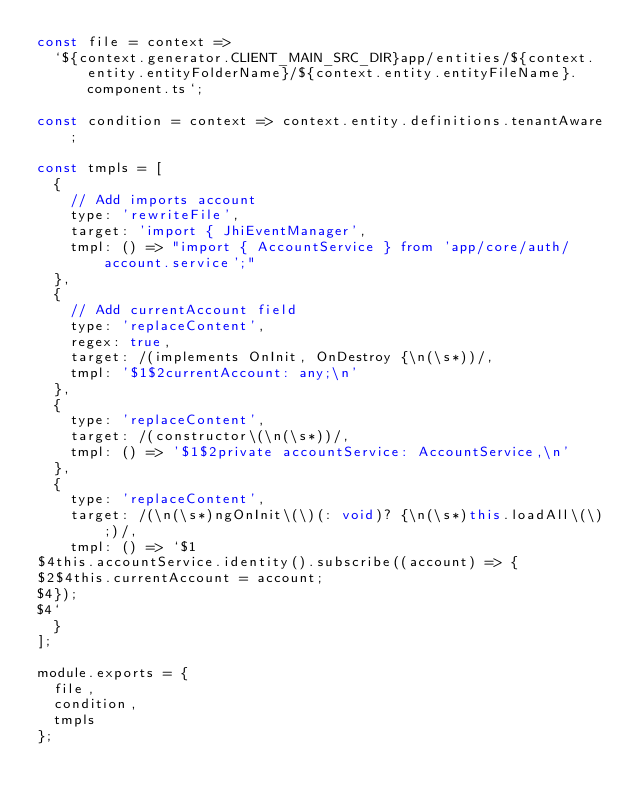<code> <loc_0><loc_0><loc_500><loc_500><_JavaScript_>const file = context =>
  `${context.generator.CLIENT_MAIN_SRC_DIR}app/entities/${context.entity.entityFolderName}/${context.entity.entityFileName}.component.ts`;

const condition = context => context.entity.definitions.tenantAware;

const tmpls = [
  {
    // Add imports account
    type: 'rewriteFile',
    target: 'import { JhiEventManager',
    tmpl: () => "import { AccountService } from 'app/core/auth/account.service';"
  },
  {
    // Add currentAccount field
    type: 'replaceContent',
    regex: true,
    target: /(implements OnInit, OnDestroy {\n(\s*))/,
    tmpl: '$1$2currentAccount: any;\n'
  },
  {
    type: 'replaceContent',
    target: /(constructor\(\n(\s*))/,
    tmpl: () => '$1$2private accountService: AccountService,\n'
  },
  {
    type: 'replaceContent',
    target: /(\n(\s*)ngOnInit\(\)(: void)? {\n(\s*)this.loadAll\(\);)/,
    tmpl: () => `$1
$4this.accountService.identity().subscribe((account) => {
$2$4this.currentAccount = account;
$4});
$4`
  }
];

module.exports = {
  file,
  condition,
  tmpls
};
</code> 